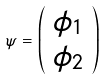<formula> <loc_0><loc_0><loc_500><loc_500>\psi = \left ( \begin{array} { c } \phi _ { 1 } \\ \phi _ { 2 } \\ \end{array} \right )</formula> 